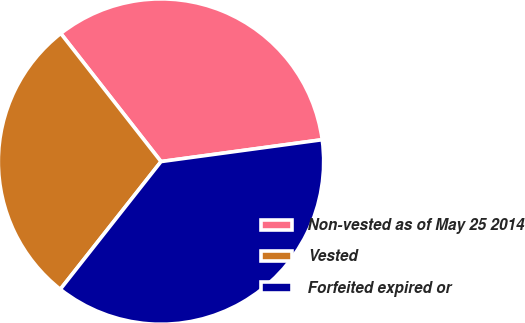Convert chart to OTSL. <chart><loc_0><loc_0><loc_500><loc_500><pie_chart><fcel>Non-vested as of May 25 2014<fcel>Vested<fcel>Forfeited expired or<nl><fcel>33.42%<fcel>28.81%<fcel>37.77%<nl></chart> 